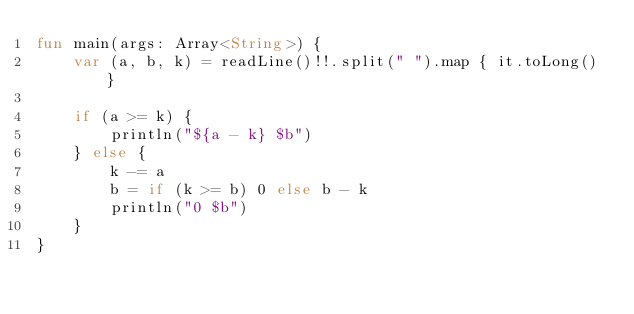<code> <loc_0><loc_0><loc_500><loc_500><_Kotlin_>fun main(args: Array<String>) {
    var (a, b, k) = readLine()!!.split(" ").map { it.toLong() }

    if (a >= k) {
        println("${a - k} $b")
    } else {
        k -= a
        b = if (k >= b) 0 else b - k
        println("0 $b")
    }
}</code> 